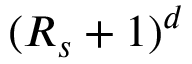Convert formula to latex. <formula><loc_0><loc_0><loc_500><loc_500>( R _ { s } + 1 ) ^ { d }</formula> 